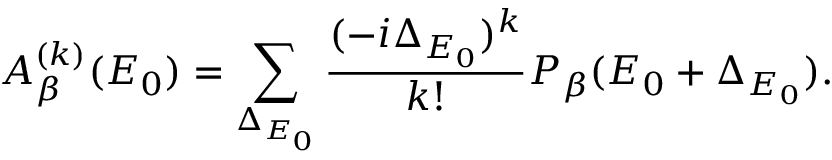Convert formula to latex. <formula><loc_0><loc_0><loc_500><loc_500>A _ { \beta } ^ { ( k ) } ( E _ { 0 } ) = \sum _ { \Delta _ { E _ { 0 } } } \frac { ( - i \Delta _ { E _ { 0 } } ) ^ { k } } { k ! } P _ { \beta } ( E _ { 0 } + \Delta _ { E _ { 0 } } ) .</formula> 